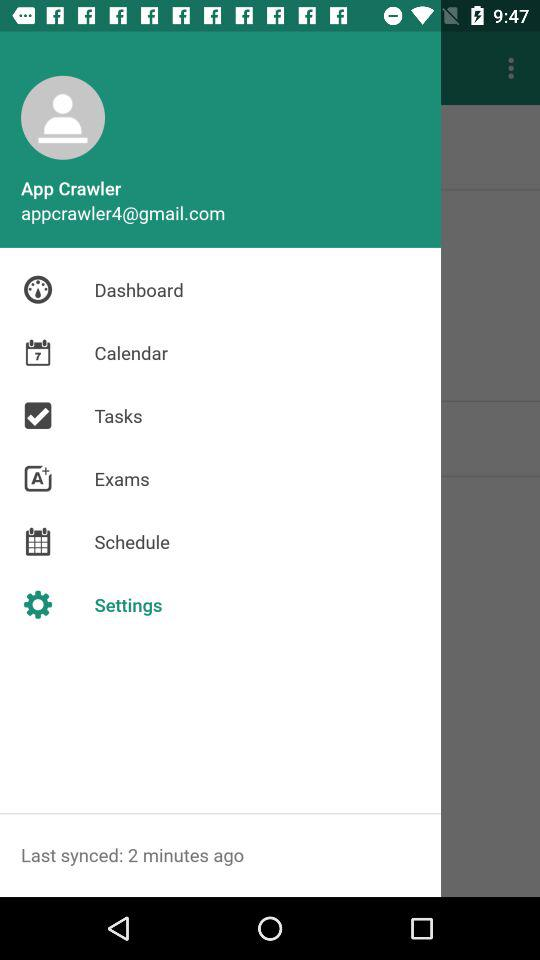How many notifications are there in "Settings"?
When the provided information is insufficient, respond with <no answer>. <no answer> 